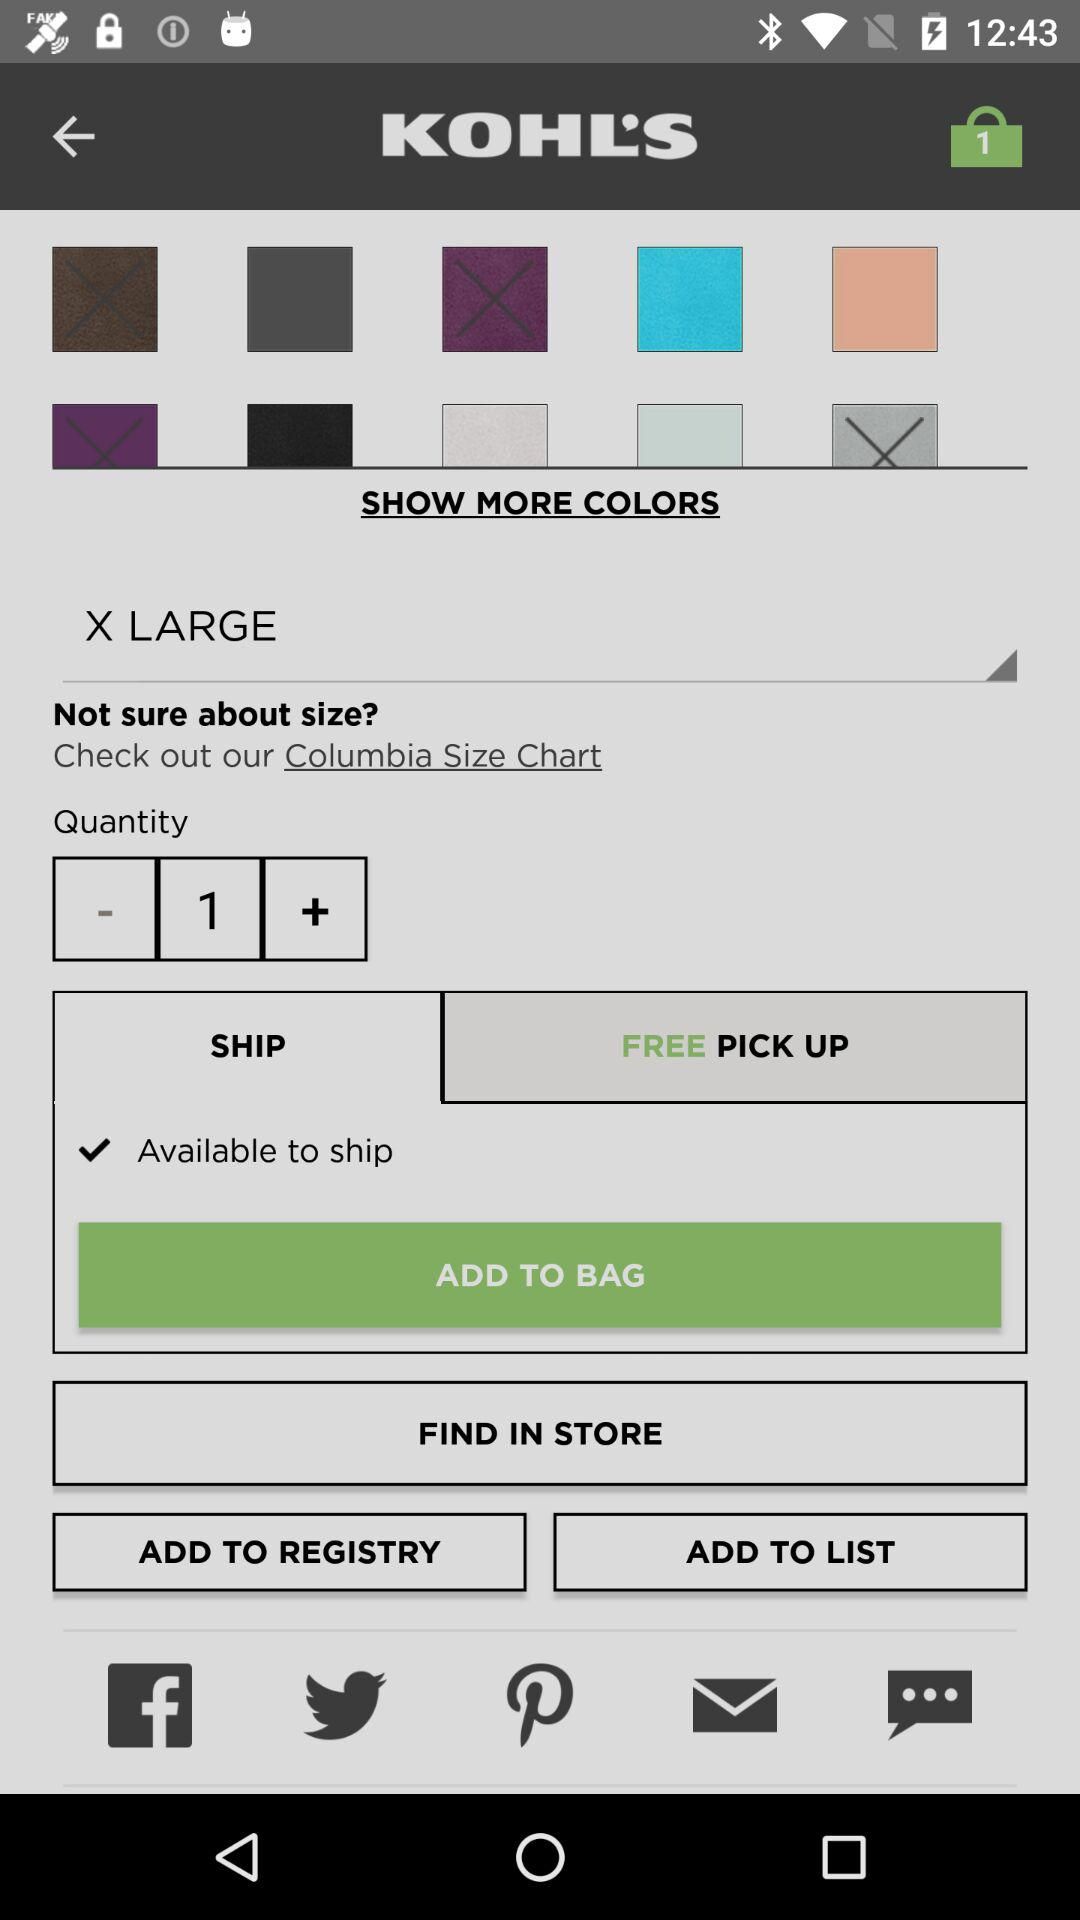How many items are in the cart?
Answer the question using a single word or phrase. 1 